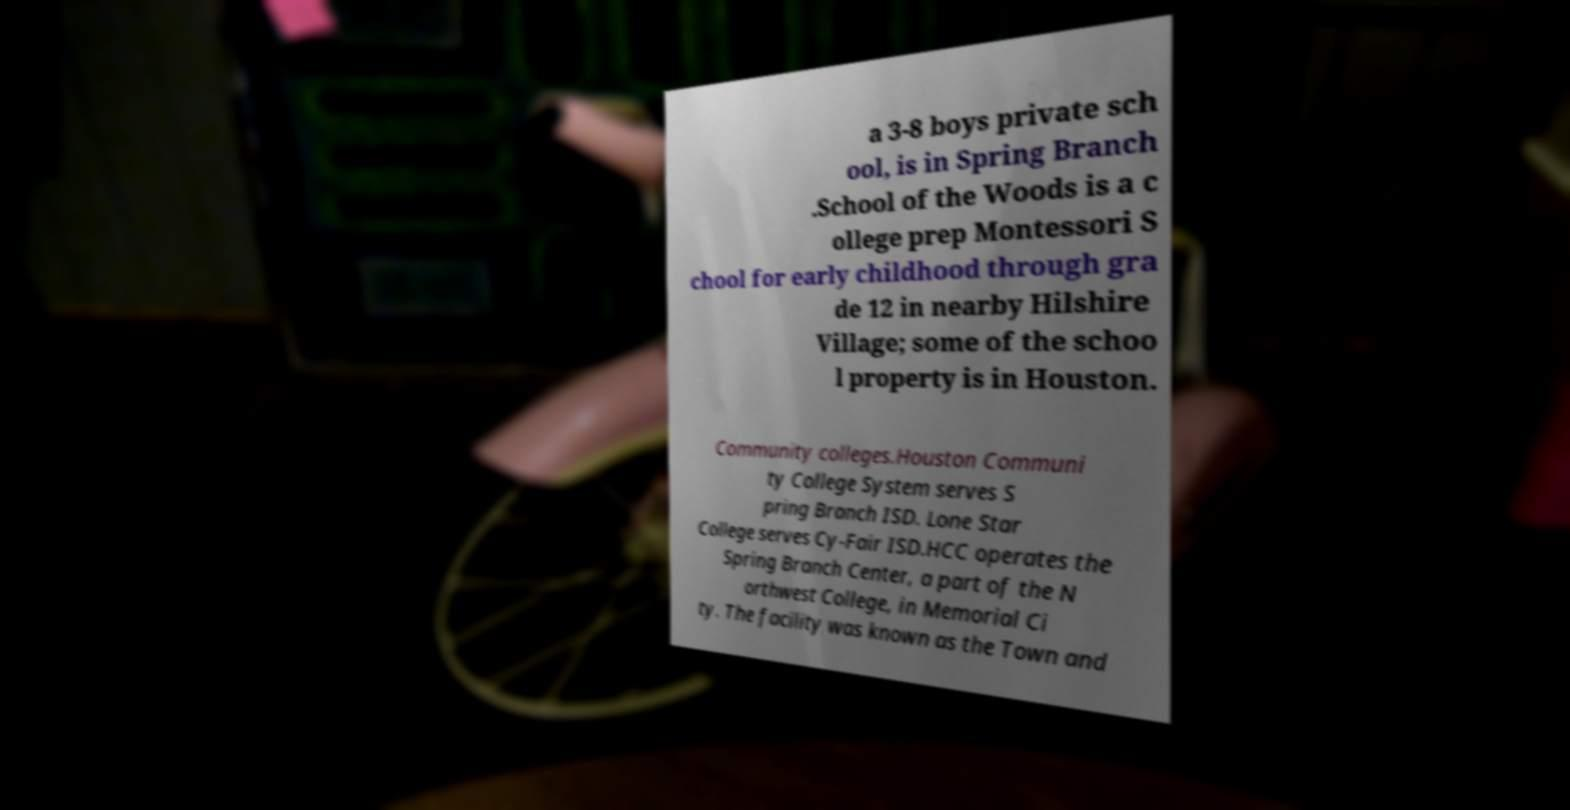Can you read and provide the text displayed in the image?This photo seems to have some interesting text. Can you extract and type it out for me? a 3-8 boys private sch ool, is in Spring Branch .School of the Woods is a c ollege prep Montessori S chool for early childhood through gra de 12 in nearby Hilshire Village; some of the schoo l property is in Houston. Community colleges.Houston Communi ty College System serves S pring Branch ISD. Lone Star College serves Cy-Fair ISD.HCC operates the Spring Branch Center, a part of the N orthwest College, in Memorial Ci ty. The facility was known as the Town and 